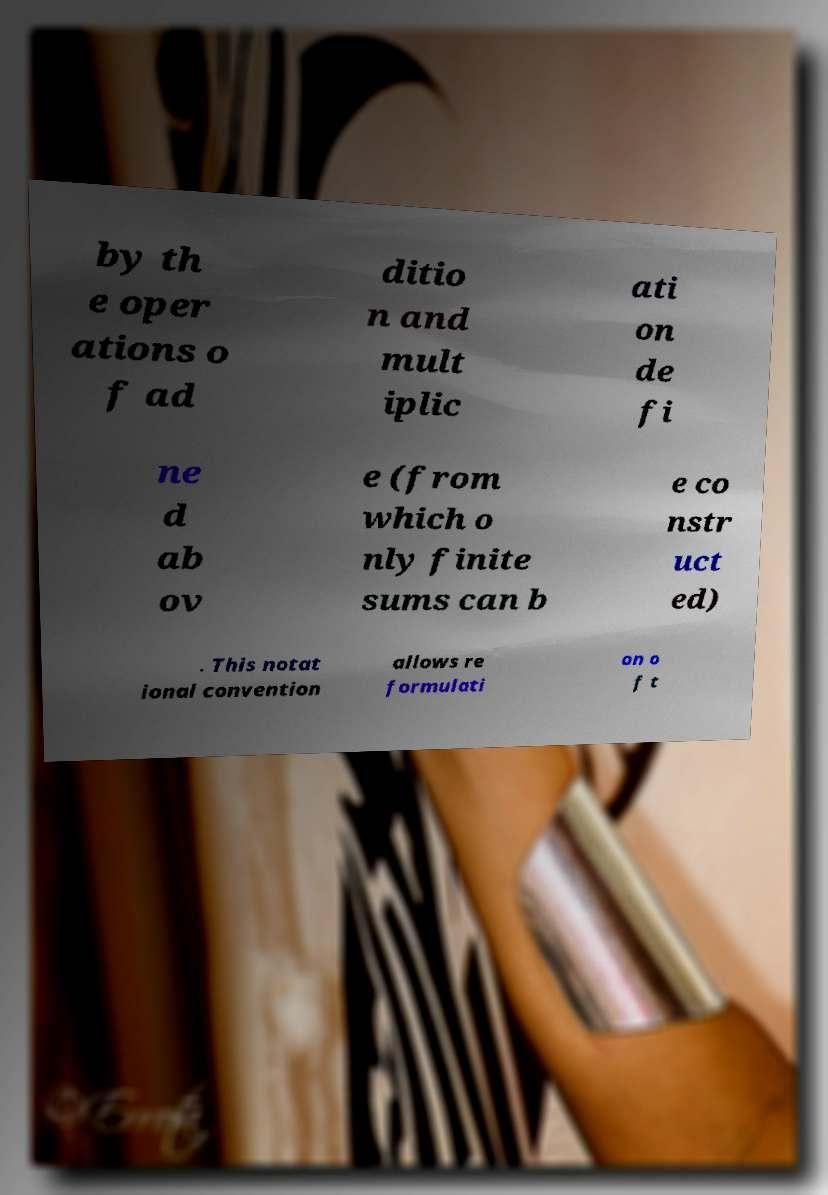For documentation purposes, I need the text within this image transcribed. Could you provide that? by th e oper ations o f ad ditio n and mult iplic ati on de fi ne d ab ov e (from which o nly finite sums can b e co nstr uct ed) . This notat ional convention allows re formulati on o f t 